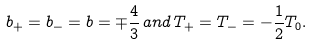Convert formula to latex. <formula><loc_0><loc_0><loc_500><loc_500>b _ { + } = b _ { - } = b = \mp \frac { 4 } { 3 } \, a n d \, T _ { + } = T _ { - } = - \frac { 1 } { 2 } T _ { 0 } .</formula> 